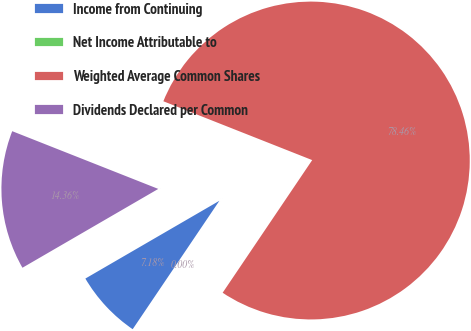Convert chart. <chart><loc_0><loc_0><loc_500><loc_500><pie_chart><fcel>Income from Continuing<fcel>Net Income Attributable to<fcel>Weighted Average Common Shares<fcel>Dividends Declared per Common<nl><fcel>7.18%<fcel>0.0%<fcel>78.46%<fcel>14.36%<nl></chart> 